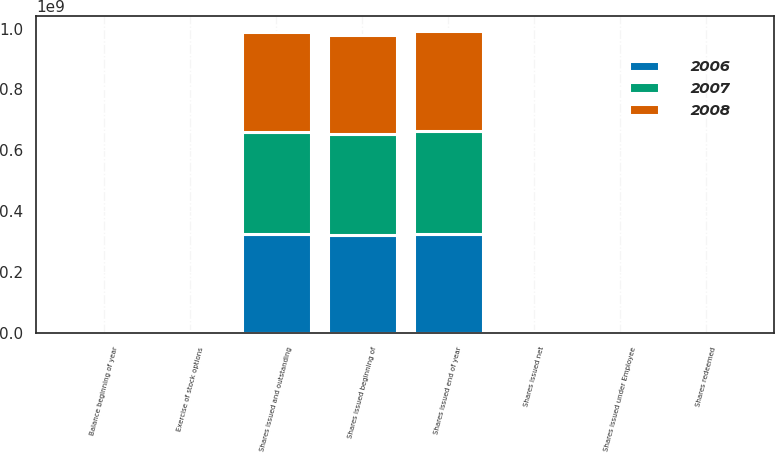Convert chart to OTSL. <chart><loc_0><loc_0><loc_500><loc_500><stacked_bar_chart><ecel><fcel>Shares issued beginning of<fcel>Shares issued net<fcel>Exercise of stock options<fcel>Shares issued under Employee<fcel>Shares issued end of year<fcel>Shares issued and outstanding<fcel>Balance beginning of year<fcel>Shares redeemed<nl><fcel>2007<fcel>3.29705e+08<fcel>3.14019e+06<fcel>2.3654e+06<fcel>203375<fcel>3.35414e+08<fcel>3.33645e+08<fcel>117231<fcel>8250<nl><fcel>2008<fcel>3.26455e+08<fcel>1.21366e+06<fcel>1.83e+06<fcel>205396<fcel>3.29705e+08<fcel>3.29705e+08<fcel>166425<fcel>49194<nl><fcel>2006<fcel>3.23323e+08<fcel>947373<fcel>1.98256e+06<fcel>202949<fcel>3.26455e+08<fcel>3.26455e+08<fcel>221675<fcel>55250<nl></chart> 